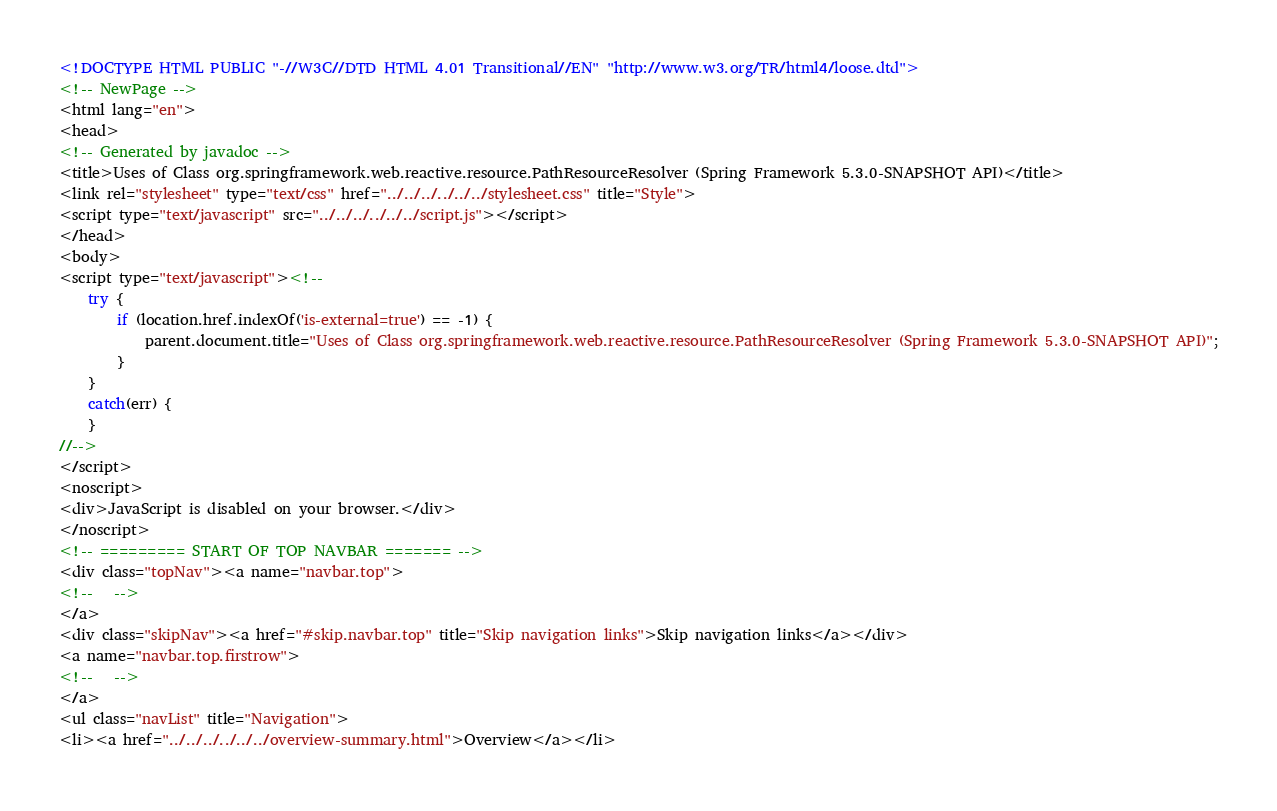Convert code to text. <code><loc_0><loc_0><loc_500><loc_500><_HTML_><!DOCTYPE HTML PUBLIC "-//W3C//DTD HTML 4.01 Transitional//EN" "http://www.w3.org/TR/html4/loose.dtd">
<!-- NewPage -->
<html lang="en">
<head>
<!-- Generated by javadoc -->
<title>Uses of Class org.springframework.web.reactive.resource.PathResourceResolver (Spring Framework 5.3.0-SNAPSHOT API)</title>
<link rel="stylesheet" type="text/css" href="../../../../../../stylesheet.css" title="Style">
<script type="text/javascript" src="../../../../../../script.js"></script>
</head>
<body>
<script type="text/javascript"><!--
    try {
        if (location.href.indexOf('is-external=true') == -1) {
            parent.document.title="Uses of Class org.springframework.web.reactive.resource.PathResourceResolver (Spring Framework 5.3.0-SNAPSHOT API)";
        }
    }
    catch(err) {
    }
//-->
</script>
<noscript>
<div>JavaScript is disabled on your browser.</div>
</noscript>
<!-- ========= START OF TOP NAVBAR ======= -->
<div class="topNav"><a name="navbar.top">
<!--   -->
</a>
<div class="skipNav"><a href="#skip.navbar.top" title="Skip navigation links">Skip navigation links</a></div>
<a name="navbar.top.firstrow">
<!--   -->
</a>
<ul class="navList" title="Navigation">
<li><a href="../../../../../../overview-summary.html">Overview</a></li></code> 